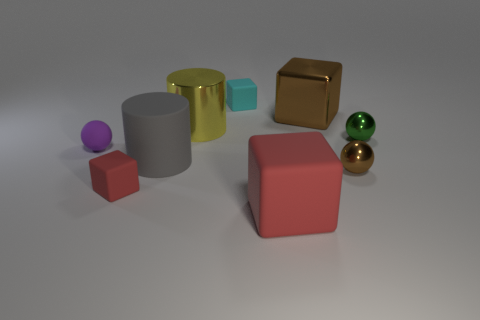Subtract all red spheres. Subtract all green cylinders. How many spheres are left? 3 Add 1 big red matte objects. How many objects exist? 10 Subtract all spheres. How many objects are left? 6 Subtract all big cyan objects. Subtract all gray things. How many objects are left? 8 Add 7 big gray rubber cylinders. How many big gray rubber cylinders are left? 8 Add 1 tiny cyan rubber things. How many tiny cyan rubber things exist? 2 Subtract 0 gray cubes. How many objects are left? 9 